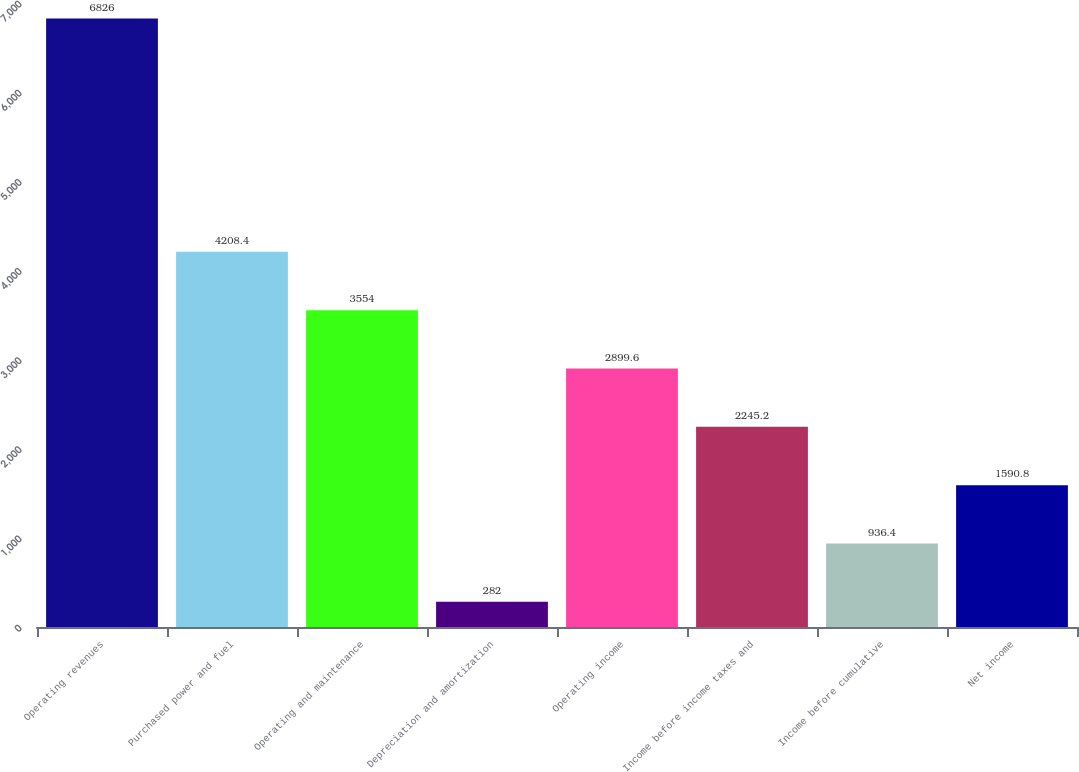Convert chart. <chart><loc_0><loc_0><loc_500><loc_500><bar_chart><fcel>Operating revenues<fcel>Purchased power and fuel<fcel>Operating and maintenance<fcel>Depreciation and amortization<fcel>Operating income<fcel>Income before income taxes and<fcel>Income before cumulative<fcel>Net income<nl><fcel>6826<fcel>4208.4<fcel>3554<fcel>282<fcel>2899.6<fcel>2245.2<fcel>936.4<fcel>1590.8<nl></chart> 